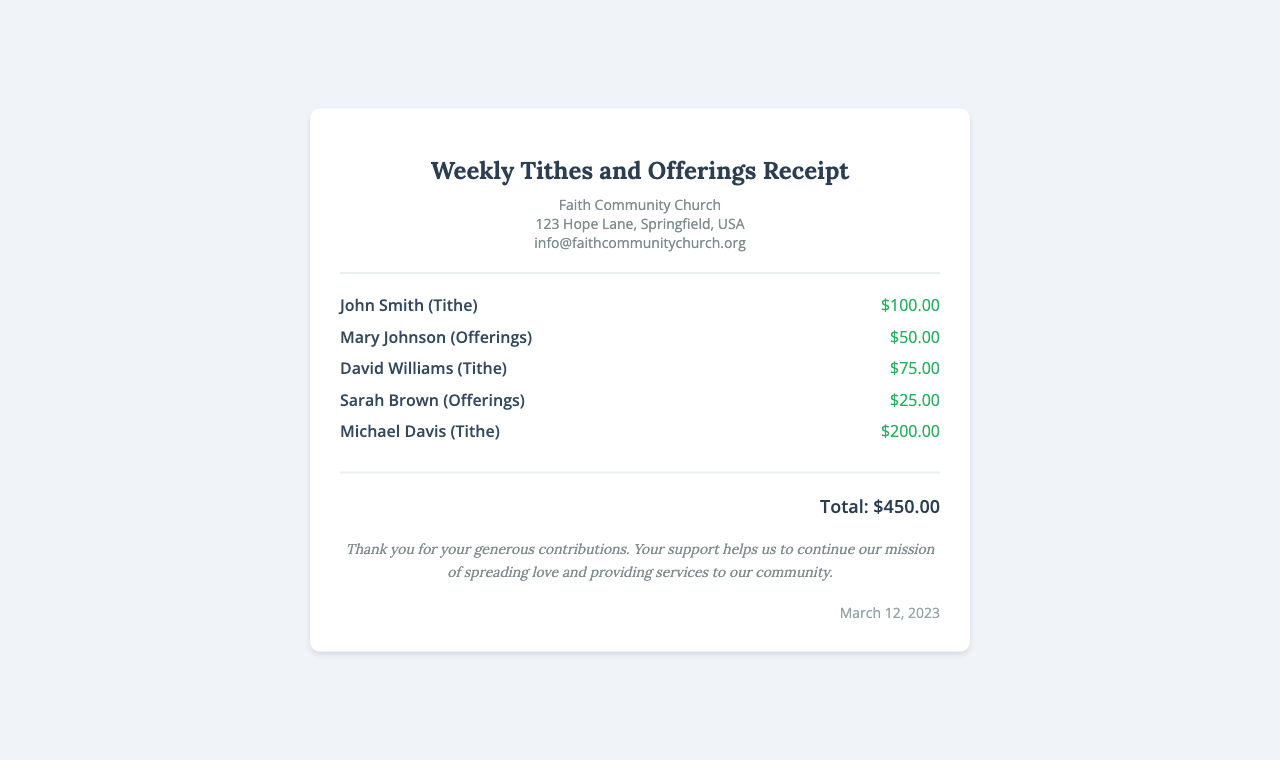What is the total amount of contributions? The total amount of contributions is found at the bottom of the document, which adds up all individual contributions made by congregants.
Answer: $450.00 Who contributed the highest amount? The contributor who donated the highest amount can be identified by comparing individual contribution amounts listed in the contributions section.
Answer: Michael Davis What type of contribution did Mary Johnson make? The type of contribution is specified in parentheses next to the contributor’s name in the contributions section.
Answer: Offerings How many congregants contributed on March 12, 2023? The number of congregants can be determined by counting the individual contribution items listed in the contributions section.
Answer: 5 What is the date on the receipt? The date is located at the bottom of the receipt, providing the specific day of the service.
Answer: March 12, 2023 What message does the church convey at the end of the receipt? The message is located beneath the total contributions, thanking the congregants for their support.
Answer: Thank you for your generous contributions. Your support helps us to continue our mission of spreading love and providing services to our community 